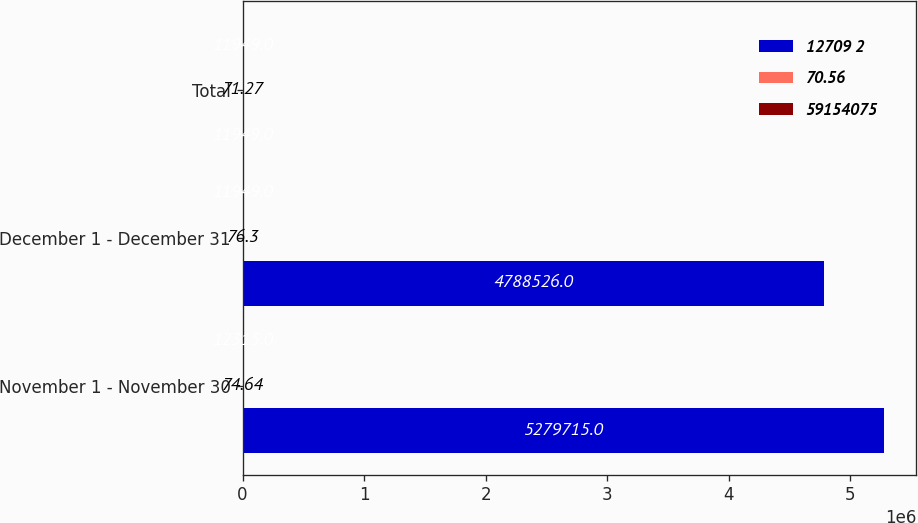<chart> <loc_0><loc_0><loc_500><loc_500><stacked_bar_chart><ecel><fcel>November 1 - November 30<fcel>December 1 - December 31<fcel>Total<nl><fcel>12709 2<fcel>5.27972e+06<fcel>4.78853e+06<fcel>11949<nl><fcel>70.56<fcel>74.64<fcel>76.3<fcel>71.27<nl><fcel>59154075<fcel>12315<fcel>11949<fcel>11949<nl></chart> 